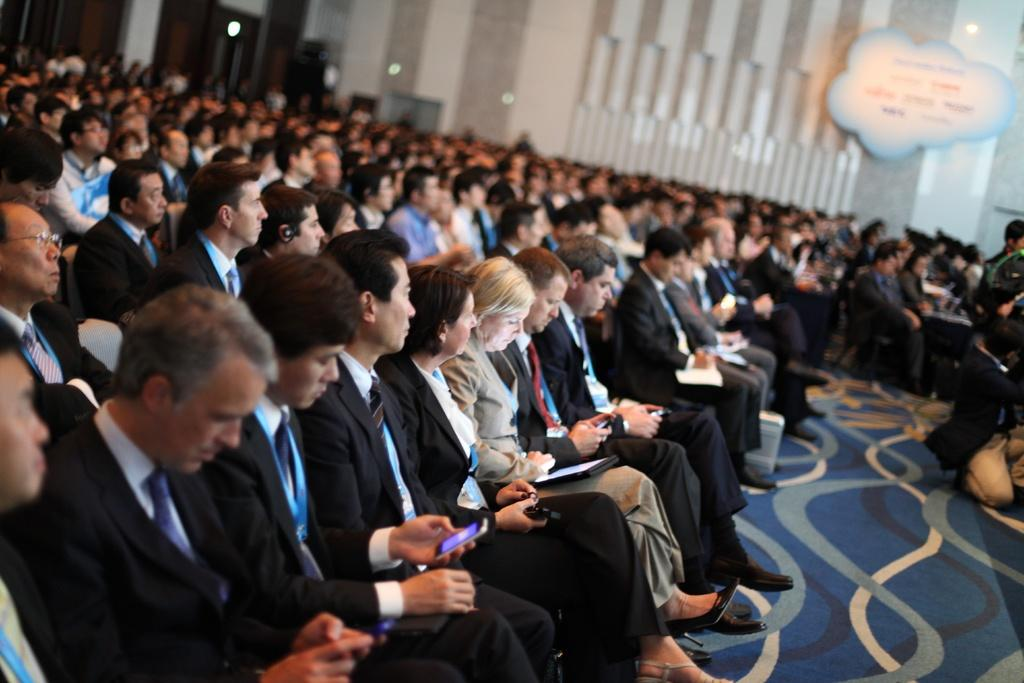How many people are in the image? There is a group of people in the image. What are the people doing in the image? The people are sitting on chairs and holding phones and papers. What is attached to the wall in the image? There is a board attached to the wall. What type of scarf is draped over the board in the image? There is no scarf present in the image; the board is not draped with any fabric. 